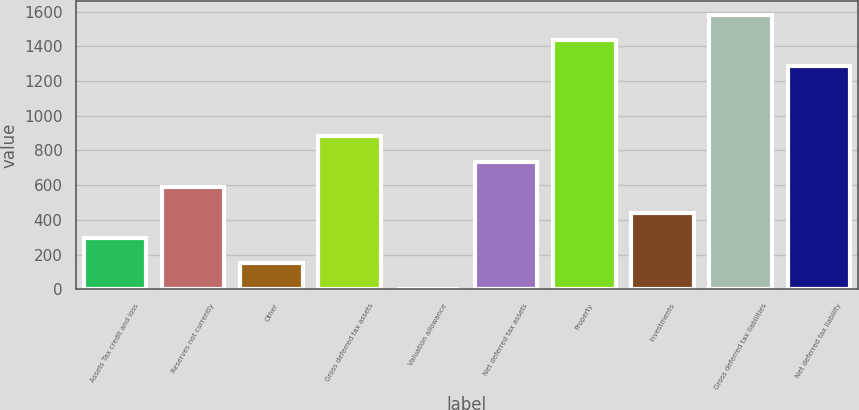Convert chart to OTSL. <chart><loc_0><loc_0><loc_500><loc_500><bar_chart><fcel>Assets Tax credit and loss<fcel>Reserves not currently<fcel>Other<fcel>Gross deferred tax assets<fcel>Valuation allowance<fcel>Net deferred tax assets<fcel>Property<fcel>Investments<fcel>Gross deferred tax liabilities<fcel>Net deferred tax liability<nl><fcel>295.3<fcel>588.9<fcel>148.5<fcel>882.5<fcel>1.7<fcel>735.7<fcel>1436.1<fcel>442.1<fcel>1582.9<fcel>1289.3<nl></chart> 